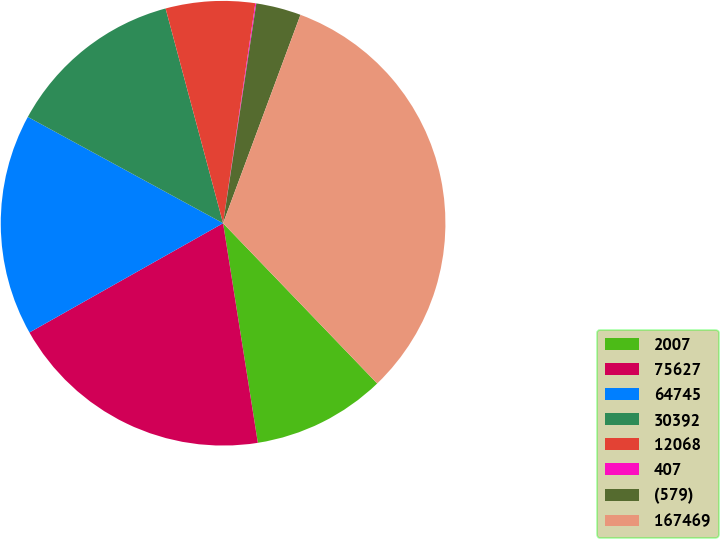Convert chart. <chart><loc_0><loc_0><loc_500><loc_500><pie_chart><fcel>2007<fcel>75627<fcel>64745<fcel>30392<fcel>12068<fcel>407<fcel>(579)<fcel>167469<nl><fcel>9.69%<fcel>19.32%<fcel>16.11%<fcel>12.9%<fcel>6.48%<fcel>0.07%<fcel>3.27%<fcel>32.15%<nl></chart> 